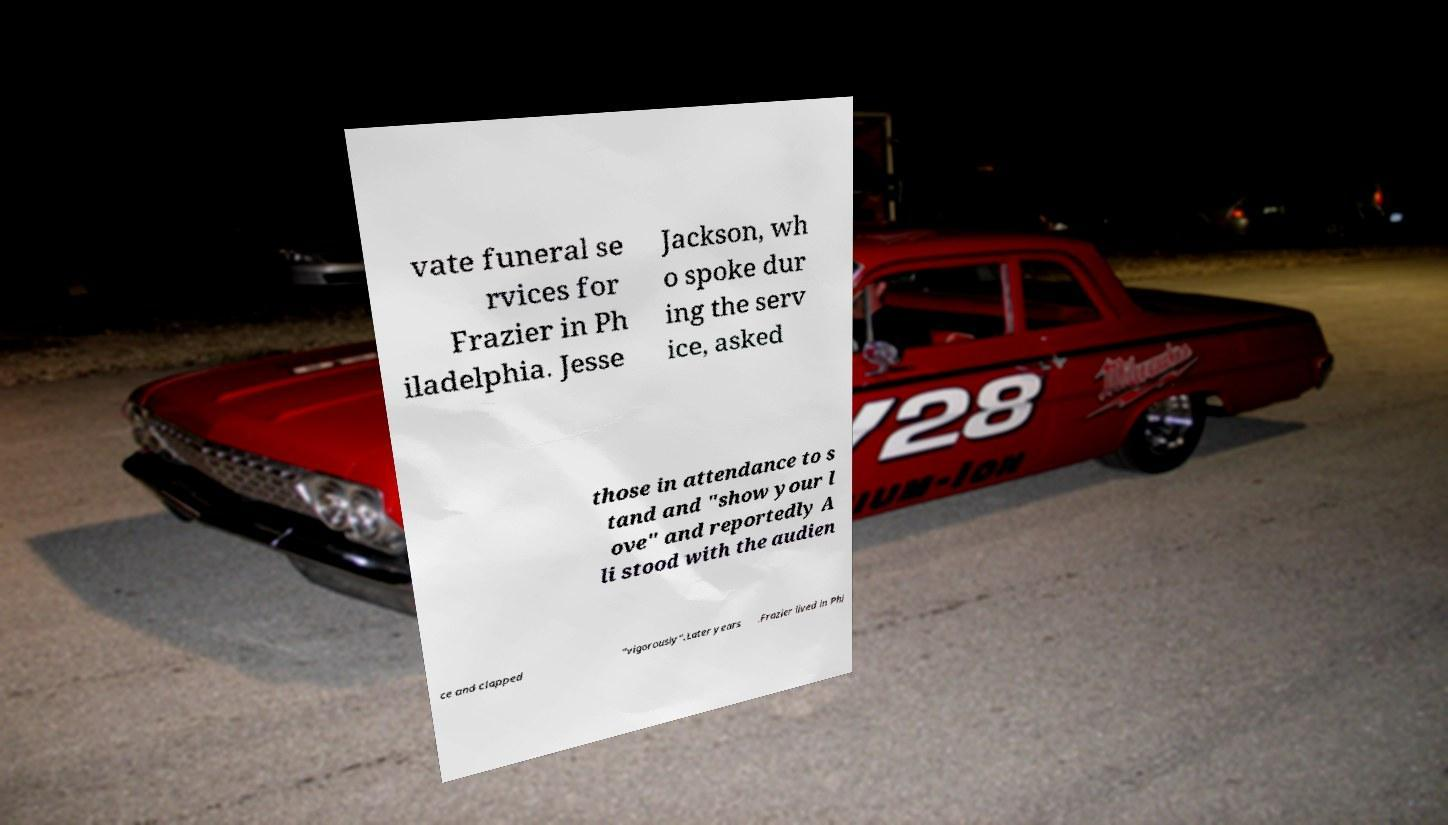There's text embedded in this image that I need extracted. Can you transcribe it verbatim? vate funeral se rvices for Frazier in Ph iladelphia. Jesse Jackson, wh o spoke dur ing the serv ice, asked those in attendance to s tand and "show your l ove" and reportedly A li stood with the audien ce and clapped "vigorously".Later years .Frazier lived in Phi 